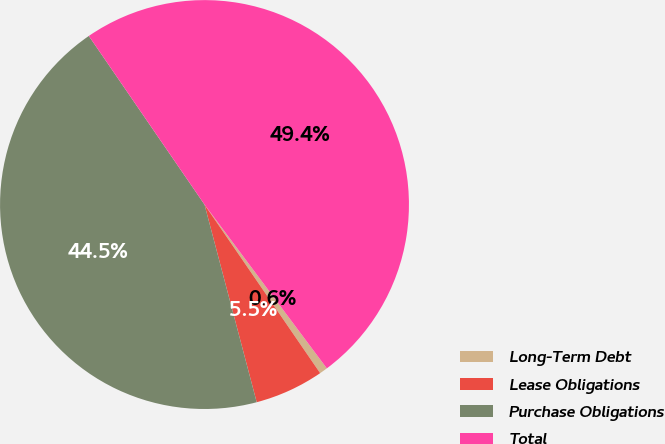Convert chart to OTSL. <chart><loc_0><loc_0><loc_500><loc_500><pie_chart><fcel>Long-Term Debt<fcel>Lease Obligations<fcel>Purchase Obligations<fcel>Total<nl><fcel>0.64%<fcel>5.46%<fcel>44.54%<fcel>49.36%<nl></chart> 